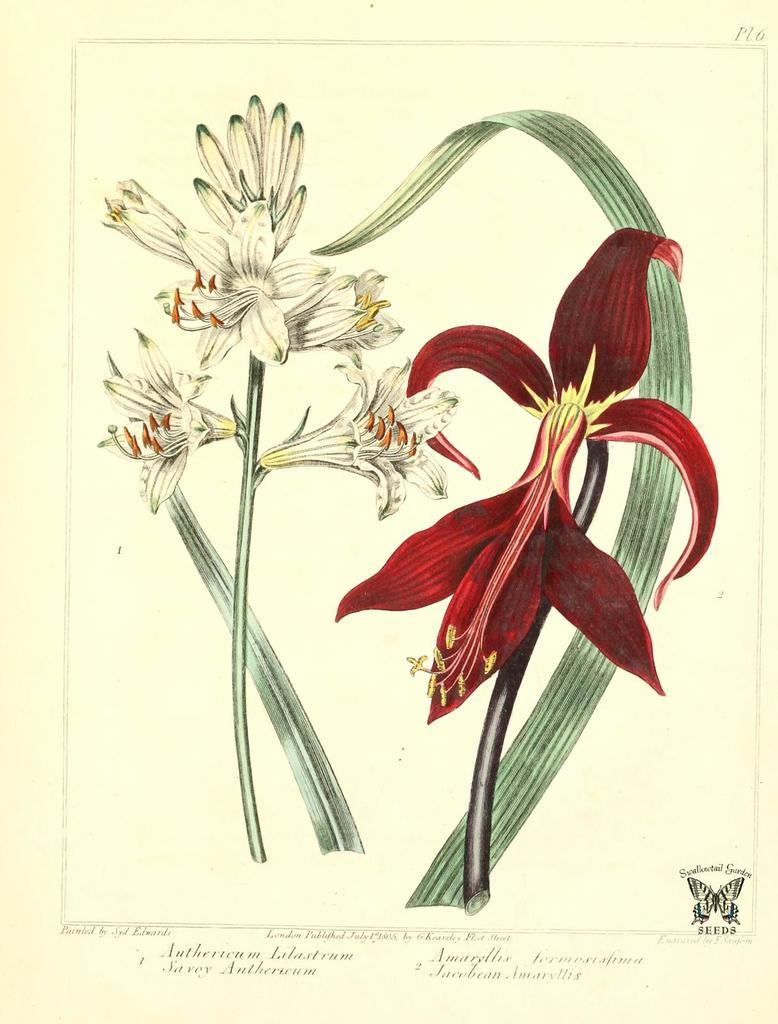What is depicted in the painting in the image? There is a painting of flowers in the image. What colors are used for the flowers in the painting? The colors of the flowers in the painting are red and white. What else can be seen in the image besides the painting? There is text written in the image. Can you tell me how many girls are depicted in the painting? There are no girls depicted in the painting; it features flowers. What type of cloud is present in the painting? There are no clouds present in the painting; it features flowers and text. 